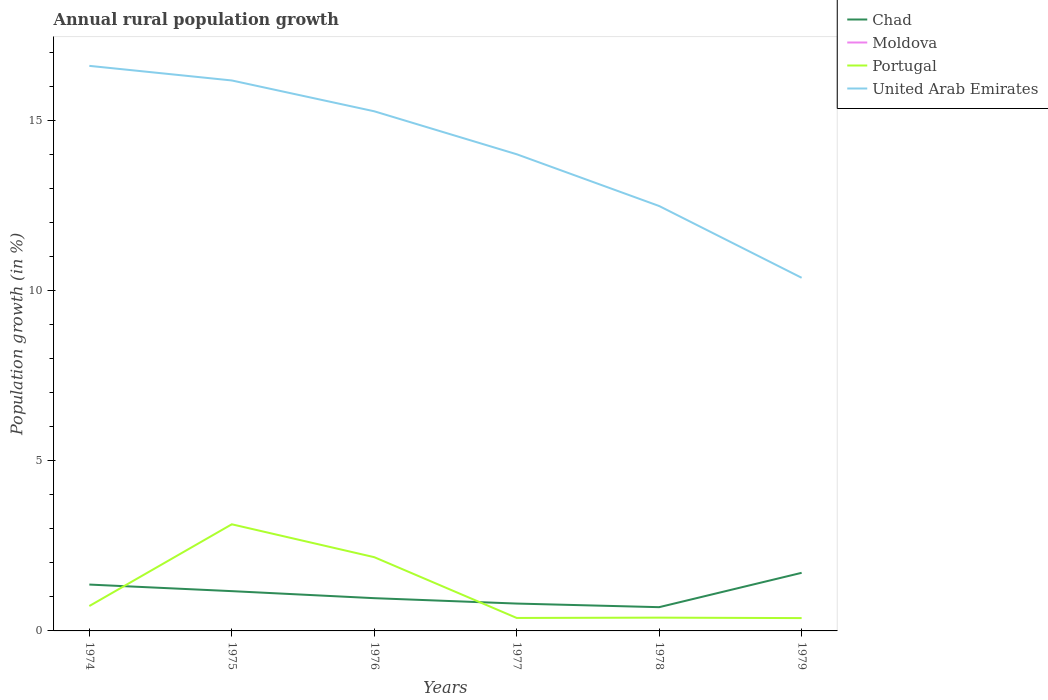How many different coloured lines are there?
Ensure brevity in your answer.  3. Does the line corresponding to Moldova intersect with the line corresponding to United Arab Emirates?
Your answer should be very brief. No. Is the number of lines equal to the number of legend labels?
Provide a short and direct response. No. Across all years, what is the maximum percentage of rural population growth in United Arab Emirates?
Ensure brevity in your answer.  10.37. What is the total percentage of rural population growth in Chad in the graph?
Provide a succinct answer. -0.74. What is the difference between the highest and the second highest percentage of rural population growth in Portugal?
Your response must be concise. 2.76. What is the difference between the highest and the lowest percentage of rural population growth in Moldova?
Your answer should be very brief. 0. How many years are there in the graph?
Keep it short and to the point. 6. Does the graph contain any zero values?
Give a very brief answer. Yes. Does the graph contain grids?
Offer a terse response. No. How many legend labels are there?
Provide a short and direct response. 4. What is the title of the graph?
Offer a terse response. Annual rural population growth. Does "New Zealand" appear as one of the legend labels in the graph?
Your answer should be very brief. No. What is the label or title of the Y-axis?
Your answer should be very brief. Population growth (in %). What is the Population growth (in %) of Chad in 1974?
Make the answer very short. 1.36. What is the Population growth (in %) in Portugal in 1974?
Make the answer very short. 0.73. What is the Population growth (in %) in United Arab Emirates in 1974?
Offer a terse response. 16.6. What is the Population growth (in %) in Chad in 1975?
Ensure brevity in your answer.  1.17. What is the Population growth (in %) of Moldova in 1975?
Offer a terse response. 0. What is the Population growth (in %) of Portugal in 1975?
Give a very brief answer. 3.13. What is the Population growth (in %) of United Arab Emirates in 1975?
Give a very brief answer. 16.17. What is the Population growth (in %) in Chad in 1976?
Keep it short and to the point. 0.96. What is the Population growth (in %) of Portugal in 1976?
Your answer should be compact. 2.17. What is the Population growth (in %) of United Arab Emirates in 1976?
Provide a short and direct response. 15.26. What is the Population growth (in %) of Chad in 1977?
Keep it short and to the point. 0.8. What is the Population growth (in %) of Moldova in 1977?
Your response must be concise. 0. What is the Population growth (in %) of Portugal in 1977?
Keep it short and to the point. 0.38. What is the Population growth (in %) of United Arab Emirates in 1977?
Give a very brief answer. 14. What is the Population growth (in %) of Chad in 1978?
Provide a short and direct response. 0.7. What is the Population growth (in %) in Portugal in 1978?
Your response must be concise. 0.39. What is the Population growth (in %) of United Arab Emirates in 1978?
Your answer should be very brief. 12.48. What is the Population growth (in %) of Chad in 1979?
Give a very brief answer. 1.71. What is the Population growth (in %) in Moldova in 1979?
Provide a succinct answer. 0. What is the Population growth (in %) of Portugal in 1979?
Ensure brevity in your answer.  0.38. What is the Population growth (in %) of United Arab Emirates in 1979?
Make the answer very short. 10.37. Across all years, what is the maximum Population growth (in %) of Chad?
Offer a terse response. 1.71. Across all years, what is the maximum Population growth (in %) in Portugal?
Your answer should be compact. 3.13. Across all years, what is the maximum Population growth (in %) in United Arab Emirates?
Your response must be concise. 16.6. Across all years, what is the minimum Population growth (in %) of Chad?
Ensure brevity in your answer.  0.7. Across all years, what is the minimum Population growth (in %) of Portugal?
Your response must be concise. 0.38. Across all years, what is the minimum Population growth (in %) in United Arab Emirates?
Offer a terse response. 10.37. What is the total Population growth (in %) in Chad in the graph?
Offer a very short reply. 6.7. What is the total Population growth (in %) in Moldova in the graph?
Offer a very short reply. 0. What is the total Population growth (in %) of Portugal in the graph?
Keep it short and to the point. 7.18. What is the total Population growth (in %) of United Arab Emirates in the graph?
Provide a short and direct response. 84.89. What is the difference between the Population growth (in %) of Chad in 1974 and that in 1975?
Your answer should be very brief. 0.19. What is the difference between the Population growth (in %) of Portugal in 1974 and that in 1975?
Ensure brevity in your answer.  -2.4. What is the difference between the Population growth (in %) of United Arab Emirates in 1974 and that in 1975?
Ensure brevity in your answer.  0.43. What is the difference between the Population growth (in %) of Chad in 1974 and that in 1976?
Offer a terse response. 0.4. What is the difference between the Population growth (in %) of Portugal in 1974 and that in 1976?
Keep it short and to the point. -1.44. What is the difference between the Population growth (in %) of United Arab Emirates in 1974 and that in 1976?
Your answer should be compact. 1.33. What is the difference between the Population growth (in %) of Chad in 1974 and that in 1977?
Make the answer very short. 0.56. What is the difference between the Population growth (in %) of Portugal in 1974 and that in 1977?
Ensure brevity in your answer.  0.35. What is the difference between the Population growth (in %) of United Arab Emirates in 1974 and that in 1977?
Provide a short and direct response. 2.6. What is the difference between the Population growth (in %) of Chad in 1974 and that in 1978?
Your response must be concise. 0.66. What is the difference between the Population growth (in %) of Portugal in 1974 and that in 1978?
Offer a terse response. 0.34. What is the difference between the Population growth (in %) of United Arab Emirates in 1974 and that in 1978?
Provide a short and direct response. 4.12. What is the difference between the Population growth (in %) in Chad in 1974 and that in 1979?
Your answer should be very brief. -0.34. What is the difference between the Population growth (in %) in Portugal in 1974 and that in 1979?
Your answer should be compact. 0.35. What is the difference between the Population growth (in %) of United Arab Emirates in 1974 and that in 1979?
Provide a short and direct response. 6.23. What is the difference between the Population growth (in %) in Chad in 1975 and that in 1976?
Your answer should be very brief. 0.21. What is the difference between the Population growth (in %) of Portugal in 1975 and that in 1976?
Offer a terse response. 0.97. What is the difference between the Population growth (in %) of United Arab Emirates in 1975 and that in 1976?
Your answer should be very brief. 0.91. What is the difference between the Population growth (in %) of Chad in 1975 and that in 1977?
Your answer should be compact. 0.37. What is the difference between the Population growth (in %) in Portugal in 1975 and that in 1977?
Your answer should be compact. 2.75. What is the difference between the Population growth (in %) in United Arab Emirates in 1975 and that in 1977?
Keep it short and to the point. 2.17. What is the difference between the Population growth (in %) in Chad in 1975 and that in 1978?
Make the answer very short. 0.47. What is the difference between the Population growth (in %) of Portugal in 1975 and that in 1978?
Your answer should be very brief. 2.74. What is the difference between the Population growth (in %) in United Arab Emirates in 1975 and that in 1978?
Provide a short and direct response. 3.69. What is the difference between the Population growth (in %) in Chad in 1975 and that in 1979?
Make the answer very short. -0.54. What is the difference between the Population growth (in %) of Portugal in 1975 and that in 1979?
Your answer should be very brief. 2.76. What is the difference between the Population growth (in %) in United Arab Emirates in 1975 and that in 1979?
Your response must be concise. 5.8. What is the difference between the Population growth (in %) in Chad in 1976 and that in 1977?
Your answer should be compact. 0.16. What is the difference between the Population growth (in %) in Portugal in 1976 and that in 1977?
Give a very brief answer. 1.79. What is the difference between the Population growth (in %) in United Arab Emirates in 1976 and that in 1977?
Your answer should be very brief. 1.26. What is the difference between the Population growth (in %) of Chad in 1976 and that in 1978?
Give a very brief answer. 0.26. What is the difference between the Population growth (in %) of Portugal in 1976 and that in 1978?
Make the answer very short. 1.78. What is the difference between the Population growth (in %) in United Arab Emirates in 1976 and that in 1978?
Your answer should be compact. 2.78. What is the difference between the Population growth (in %) in Chad in 1976 and that in 1979?
Offer a very short reply. -0.74. What is the difference between the Population growth (in %) in Portugal in 1976 and that in 1979?
Your response must be concise. 1.79. What is the difference between the Population growth (in %) of United Arab Emirates in 1976 and that in 1979?
Your answer should be very brief. 4.89. What is the difference between the Population growth (in %) of Chad in 1977 and that in 1978?
Offer a very short reply. 0.11. What is the difference between the Population growth (in %) in Portugal in 1977 and that in 1978?
Ensure brevity in your answer.  -0.01. What is the difference between the Population growth (in %) of United Arab Emirates in 1977 and that in 1978?
Provide a succinct answer. 1.52. What is the difference between the Population growth (in %) in Chad in 1977 and that in 1979?
Keep it short and to the point. -0.9. What is the difference between the Population growth (in %) of Portugal in 1977 and that in 1979?
Your answer should be compact. 0. What is the difference between the Population growth (in %) in United Arab Emirates in 1977 and that in 1979?
Provide a short and direct response. 3.63. What is the difference between the Population growth (in %) in Chad in 1978 and that in 1979?
Give a very brief answer. -1.01. What is the difference between the Population growth (in %) of Portugal in 1978 and that in 1979?
Ensure brevity in your answer.  0.01. What is the difference between the Population growth (in %) of United Arab Emirates in 1978 and that in 1979?
Offer a terse response. 2.11. What is the difference between the Population growth (in %) of Chad in 1974 and the Population growth (in %) of Portugal in 1975?
Provide a succinct answer. -1.77. What is the difference between the Population growth (in %) in Chad in 1974 and the Population growth (in %) in United Arab Emirates in 1975?
Provide a succinct answer. -14.81. What is the difference between the Population growth (in %) in Portugal in 1974 and the Population growth (in %) in United Arab Emirates in 1975?
Provide a short and direct response. -15.44. What is the difference between the Population growth (in %) in Chad in 1974 and the Population growth (in %) in Portugal in 1976?
Keep it short and to the point. -0.8. What is the difference between the Population growth (in %) of Chad in 1974 and the Population growth (in %) of United Arab Emirates in 1976?
Your response must be concise. -13.9. What is the difference between the Population growth (in %) of Portugal in 1974 and the Population growth (in %) of United Arab Emirates in 1976?
Give a very brief answer. -14.53. What is the difference between the Population growth (in %) in Chad in 1974 and the Population growth (in %) in Portugal in 1977?
Provide a short and direct response. 0.98. What is the difference between the Population growth (in %) of Chad in 1974 and the Population growth (in %) of United Arab Emirates in 1977?
Your answer should be compact. -12.64. What is the difference between the Population growth (in %) of Portugal in 1974 and the Population growth (in %) of United Arab Emirates in 1977?
Provide a succinct answer. -13.27. What is the difference between the Population growth (in %) in Chad in 1974 and the Population growth (in %) in Portugal in 1978?
Offer a very short reply. 0.97. What is the difference between the Population growth (in %) in Chad in 1974 and the Population growth (in %) in United Arab Emirates in 1978?
Provide a short and direct response. -11.12. What is the difference between the Population growth (in %) of Portugal in 1974 and the Population growth (in %) of United Arab Emirates in 1978?
Provide a succinct answer. -11.75. What is the difference between the Population growth (in %) in Chad in 1974 and the Population growth (in %) in Portugal in 1979?
Keep it short and to the point. 0.99. What is the difference between the Population growth (in %) of Chad in 1974 and the Population growth (in %) of United Arab Emirates in 1979?
Provide a succinct answer. -9.01. What is the difference between the Population growth (in %) of Portugal in 1974 and the Population growth (in %) of United Arab Emirates in 1979?
Keep it short and to the point. -9.64. What is the difference between the Population growth (in %) of Chad in 1975 and the Population growth (in %) of Portugal in 1976?
Your response must be concise. -1. What is the difference between the Population growth (in %) of Chad in 1975 and the Population growth (in %) of United Arab Emirates in 1976?
Provide a short and direct response. -14.1. What is the difference between the Population growth (in %) in Portugal in 1975 and the Population growth (in %) in United Arab Emirates in 1976?
Provide a succinct answer. -12.13. What is the difference between the Population growth (in %) of Chad in 1975 and the Population growth (in %) of Portugal in 1977?
Ensure brevity in your answer.  0.79. What is the difference between the Population growth (in %) in Chad in 1975 and the Population growth (in %) in United Arab Emirates in 1977?
Offer a very short reply. -12.83. What is the difference between the Population growth (in %) in Portugal in 1975 and the Population growth (in %) in United Arab Emirates in 1977?
Offer a terse response. -10.87. What is the difference between the Population growth (in %) in Chad in 1975 and the Population growth (in %) in Portugal in 1978?
Ensure brevity in your answer.  0.78. What is the difference between the Population growth (in %) of Chad in 1975 and the Population growth (in %) of United Arab Emirates in 1978?
Your answer should be very brief. -11.31. What is the difference between the Population growth (in %) of Portugal in 1975 and the Population growth (in %) of United Arab Emirates in 1978?
Provide a succinct answer. -9.35. What is the difference between the Population growth (in %) in Chad in 1975 and the Population growth (in %) in Portugal in 1979?
Provide a short and direct response. 0.79. What is the difference between the Population growth (in %) in Chad in 1975 and the Population growth (in %) in United Arab Emirates in 1979?
Your answer should be compact. -9.21. What is the difference between the Population growth (in %) of Portugal in 1975 and the Population growth (in %) of United Arab Emirates in 1979?
Give a very brief answer. -7.24. What is the difference between the Population growth (in %) in Chad in 1976 and the Population growth (in %) in Portugal in 1977?
Provide a succinct answer. 0.58. What is the difference between the Population growth (in %) of Chad in 1976 and the Population growth (in %) of United Arab Emirates in 1977?
Give a very brief answer. -13.04. What is the difference between the Population growth (in %) in Portugal in 1976 and the Population growth (in %) in United Arab Emirates in 1977?
Your answer should be compact. -11.84. What is the difference between the Population growth (in %) of Chad in 1976 and the Population growth (in %) of Portugal in 1978?
Provide a succinct answer. 0.57. What is the difference between the Population growth (in %) in Chad in 1976 and the Population growth (in %) in United Arab Emirates in 1978?
Your answer should be compact. -11.52. What is the difference between the Population growth (in %) in Portugal in 1976 and the Population growth (in %) in United Arab Emirates in 1978?
Your response must be concise. -10.32. What is the difference between the Population growth (in %) in Chad in 1976 and the Population growth (in %) in Portugal in 1979?
Give a very brief answer. 0.59. What is the difference between the Population growth (in %) of Chad in 1976 and the Population growth (in %) of United Arab Emirates in 1979?
Offer a terse response. -9.41. What is the difference between the Population growth (in %) in Portugal in 1976 and the Population growth (in %) in United Arab Emirates in 1979?
Provide a succinct answer. -8.21. What is the difference between the Population growth (in %) in Chad in 1977 and the Population growth (in %) in Portugal in 1978?
Make the answer very short. 0.41. What is the difference between the Population growth (in %) of Chad in 1977 and the Population growth (in %) of United Arab Emirates in 1978?
Provide a short and direct response. -11.68. What is the difference between the Population growth (in %) of Portugal in 1977 and the Population growth (in %) of United Arab Emirates in 1978?
Offer a terse response. -12.1. What is the difference between the Population growth (in %) in Chad in 1977 and the Population growth (in %) in Portugal in 1979?
Provide a short and direct response. 0.43. What is the difference between the Population growth (in %) of Chad in 1977 and the Population growth (in %) of United Arab Emirates in 1979?
Provide a short and direct response. -9.57. What is the difference between the Population growth (in %) in Portugal in 1977 and the Population growth (in %) in United Arab Emirates in 1979?
Ensure brevity in your answer.  -9.99. What is the difference between the Population growth (in %) of Chad in 1978 and the Population growth (in %) of Portugal in 1979?
Offer a very short reply. 0.32. What is the difference between the Population growth (in %) in Chad in 1978 and the Population growth (in %) in United Arab Emirates in 1979?
Your answer should be compact. -9.68. What is the difference between the Population growth (in %) in Portugal in 1978 and the Population growth (in %) in United Arab Emirates in 1979?
Offer a terse response. -9.98. What is the average Population growth (in %) of Chad per year?
Provide a short and direct response. 1.12. What is the average Population growth (in %) in Portugal per year?
Your response must be concise. 1.2. What is the average Population growth (in %) of United Arab Emirates per year?
Offer a very short reply. 14.15. In the year 1974, what is the difference between the Population growth (in %) in Chad and Population growth (in %) in Portugal?
Provide a short and direct response. 0.63. In the year 1974, what is the difference between the Population growth (in %) in Chad and Population growth (in %) in United Arab Emirates?
Make the answer very short. -15.24. In the year 1974, what is the difference between the Population growth (in %) in Portugal and Population growth (in %) in United Arab Emirates?
Provide a short and direct response. -15.87. In the year 1975, what is the difference between the Population growth (in %) in Chad and Population growth (in %) in Portugal?
Keep it short and to the point. -1.96. In the year 1975, what is the difference between the Population growth (in %) of Chad and Population growth (in %) of United Arab Emirates?
Make the answer very short. -15. In the year 1975, what is the difference between the Population growth (in %) of Portugal and Population growth (in %) of United Arab Emirates?
Offer a very short reply. -13.04. In the year 1976, what is the difference between the Population growth (in %) in Chad and Population growth (in %) in Portugal?
Keep it short and to the point. -1.2. In the year 1976, what is the difference between the Population growth (in %) in Chad and Population growth (in %) in United Arab Emirates?
Your answer should be very brief. -14.3. In the year 1976, what is the difference between the Population growth (in %) in Portugal and Population growth (in %) in United Arab Emirates?
Provide a short and direct response. -13.1. In the year 1977, what is the difference between the Population growth (in %) of Chad and Population growth (in %) of Portugal?
Ensure brevity in your answer.  0.42. In the year 1977, what is the difference between the Population growth (in %) of Chad and Population growth (in %) of United Arab Emirates?
Make the answer very short. -13.2. In the year 1977, what is the difference between the Population growth (in %) of Portugal and Population growth (in %) of United Arab Emirates?
Provide a short and direct response. -13.62. In the year 1978, what is the difference between the Population growth (in %) of Chad and Population growth (in %) of Portugal?
Your answer should be very brief. 0.31. In the year 1978, what is the difference between the Population growth (in %) of Chad and Population growth (in %) of United Arab Emirates?
Make the answer very short. -11.78. In the year 1978, what is the difference between the Population growth (in %) of Portugal and Population growth (in %) of United Arab Emirates?
Ensure brevity in your answer.  -12.09. In the year 1979, what is the difference between the Population growth (in %) in Chad and Population growth (in %) in Portugal?
Ensure brevity in your answer.  1.33. In the year 1979, what is the difference between the Population growth (in %) of Chad and Population growth (in %) of United Arab Emirates?
Ensure brevity in your answer.  -8.67. In the year 1979, what is the difference between the Population growth (in %) of Portugal and Population growth (in %) of United Arab Emirates?
Keep it short and to the point. -10. What is the ratio of the Population growth (in %) of Chad in 1974 to that in 1975?
Offer a terse response. 1.17. What is the ratio of the Population growth (in %) in Portugal in 1974 to that in 1975?
Give a very brief answer. 0.23. What is the ratio of the Population growth (in %) in United Arab Emirates in 1974 to that in 1975?
Your answer should be very brief. 1.03. What is the ratio of the Population growth (in %) of Chad in 1974 to that in 1976?
Give a very brief answer. 1.42. What is the ratio of the Population growth (in %) in Portugal in 1974 to that in 1976?
Provide a succinct answer. 0.34. What is the ratio of the Population growth (in %) of United Arab Emirates in 1974 to that in 1976?
Provide a succinct answer. 1.09. What is the ratio of the Population growth (in %) of Chad in 1974 to that in 1977?
Give a very brief answer. 1.69. What is the ratio of the Population growth (in %) in Portugal in 1974 to that in 1977?
Your answer should be compact. 1.92. What is the ratio of the Population growth (in %) in United Arab Emirates in 1974 to that in 1977?
Your answer should be compact. 1.19. What is the ratio of the Population growth (in %) of Chad in 1974 to that in 1978?
Ensure brevity in your answer.  1.95. What is the ratio of the Population growth (in %) in Portugal in 1974 to that in 1978?
Ensure brevity in your answer.  1.87. What is the ratio of the Population growth (in %) of United Arab Emirates in 1974 to that in 1978?
Your response must be concise. 1.33. What is the ratio of the Population growth (in %) in Chad in 1974 to that in 1979?
Offer a very short reply. 0.8. What is the ratio of the Population growth (in %) of Portugal in 1974 to that in 1979?
Your answer should be compact. 1.94. What is the ratio of the Population growth (in %) of United Arab Emirates in 1974 to that in 1979?
Provide a short and direct response. 1.6. What is the ratio of the Population growth (in %) in Chad in 1975 to that in 1976?
Offer a very short reply. 1.21. What is the ratio of the Population growth (in %) of Portugal in 1975 to that in 1976?
Provide a short and direct response. 1.45. What is the ratio of the Population growth (in %) in United Arab Emirates in 1975 to that in 1976?
Provide a succinct answer. 1.06. What is the ratio of the Population growth (in %) of Chad in 1975 to that in 1977?
Your response must be concise. 1.45. What is the ratio of the Population growth (in %) of Portugal in 1975 to that in 1977?
Your response must be concise. 8.22. What is the ratio of the Population growth (in %) of United Arab Emirates in 1975 to that in 1977?
Keep it short and to the point. 1.15. What is the ratio of the Population growth (in %) of Chad in 1975 to that in 1978?
Make the answer very short. 1.67. What is the ratio of the Population growth (in %) in Portugal in 1975 to that in 1978?
Provide a succinct answer. 8.03. What is the ratio of the Population growth (in %) in United Arab Emirates in 1975 to that in 1978?
Offer a terse response. 1.3. What is the ratio of the Population growth (in %) of Chad in 1975 to that in 1979?
Provide a succinct answer. 0.68. What is the ratio of the Population growth (in %) in Portugal in 1975 to that in 1979?
Give a very brief answer. 8.31. What is the ratio of the Population growth (in %) of United Arab Emirates in 1975 to that in 1979?
Give a very brief answer. 1.56. What is the ratio of the Population growth (in %) in Chad in 1976 to that in 1977?
Provide a succinct answer. 1.2. What is the ratio of the Population growth (in %) in Portugal in 1976 to that in 1977?
Your answer should be compact. 5.68. What is the ratio of the Population growth (in %) of United Arab Emirates in 1976 to that in 1977?
Offer a terse response. 1.09. What is the ratio of the Population growth (in %) in Chad in 1976 to that in 1978?
Provide a succinct answer. 1.38. What is the ratio of the Population growth (in %) in Portugal in 1976 to that in 1978?
Provide a short and direct response. 5.55. What is the ratio of the Population growth (in %) in United Arab Emirates in 1976 to that in 1978?
Your response must be concise. 1.22. What is the ratio of the Population growth (in %) of Chad in 1976 to that in 1979?
Your answer should be compact. 0.56. What is the ratio of the Population growth (in %) of Portugal in 1976 to that in 1979?
Offer a very short reply. 5.75. What is the ratio of the Population growth (in %) in United Arab Emirates in 1976 to that in 1979?
Keep it short and to the point. 1.47. What is the ratio of the Population growth (in %) in Chad in 1977 to that in 1978?
Provide a short and direct response. 1.15. What is the ratio of the Population growth (in %) of Portugal in 1977 to that in 1978?
Keep it short and to the point. 0.98. What is the ratio of the Population growth (in %) in United Arab Emirates in 1977 to that in 1978?
Ensure brevity in your answer.  1.12. What is the ratio of the Population growth (in %) of Chad in 1977 to that in 1979?
Your response must be concise. 0.47. What is the ratio of the Population growth (in %) in Portugal in 1977 to that in 1979?
Your response must be concise. 1.01. What is the ratio of the Population growth (in %) of United Arab Emirates in 1977 to that in 1979?
Keep it short and to the point. 1.35. What is the ratio of the Population growth (in %) of Chad in 1978 to that in 1979?
Offer a terse response. 0.41. What is the ratio of the Population growth (in %) in Portugal in 1978 to that in 1979?
Your answer should be compact. 1.04. What is the ratio of the Population growth (in %) of United Arab Emirates in 1978 to that in 1979?
Your answer should be compact. 1.2. What is the difference between the highest and the second highest Population growth (in %) of Chad?
Ensure brevity in your answer.  0.34. What is the difference between the highest and the second highest Population growth (in %) in Portugal?
Give a very brief answer. 0.97. What is the difference between the highest and the second highest Population growth (in %) of United Arab Emirates?
Keep it short and to the point. 0.43. What is the difference between the highest and the lowest Population growth (in %) in Chad?
Keep it short and to the point. 1.01. What is the difference between the highest and the lowest Population growth (in %) of Portugal?
Your response must be concise. 2.76. What is the difference between the highest and the lowest Population growth (in %) of United Arab Emirates?
Your answer should be very brief. 6.23. 